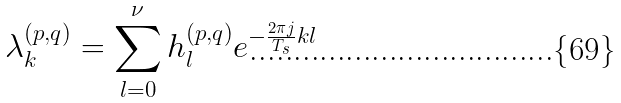Convert formula to latex. <formula><loc_0><loc_0><loc_500><loc_500>\lambda _ { k } ^ { ( p , q ) } & = \sum _ { l = 0 } ^ { \nu } h _ { l } ^ { ( p , q ) } e ^ { - \frac { 2 \pi j } { T _ { s } } k l }</formula> 